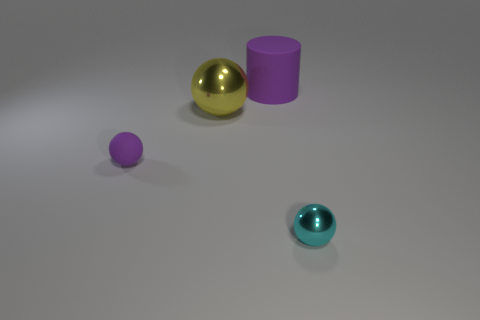What kind of lighting seems to be used in this scene? The scene is softly illuminated by what appears to be a diffused, overhead light source, casting gentle shadows beneath each object and giving the shapes a soft-edged appearance without harsh contrast. 